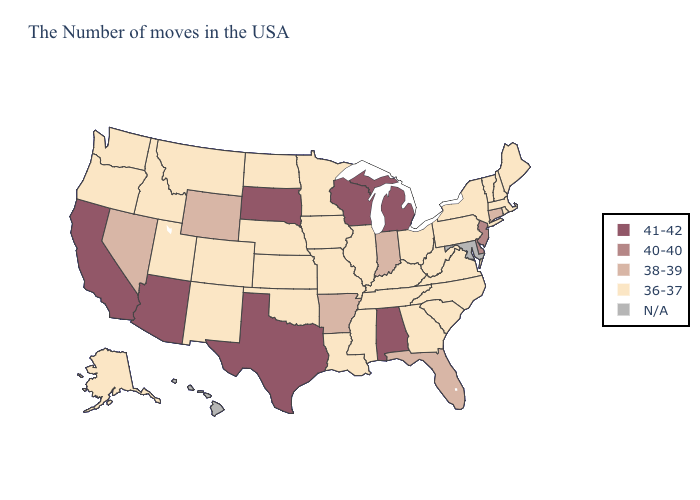Which states have the highest value in the USA?
Quick response, please. Michigan, Alabama, Wisconsin, Texas, South Dakota, Arizona, California. Does the first symbol in the legend represent the smallest category?
Short answer required. No. Name the states that have a value in the range 40-40?
Short answer required. New Jersey, Delaware. Name the states that have a value in the range 40-40?
Write a very short answer. New Jersey, Delaware. Among the states that border Arizona , does Nevada have the highest value?
Short answer required. No. Among the states that border Iowa , which have the highest value?
Concise answer only. Wisconsin, South Dakota. Which states have the highest value in the USA?
Short answer required. Michigan, Alabama, Wisconsin, Texas, South Dakota, Arizona, California. Name the states that have a value in the range 36-37?
Answer briefly. Maine, Massachusetts, Rhode Island, New Hampshire, Vermont, New York, Pennsylvania, Virginia, North Carolina, South Carolina, West Virginia, Ohio, Georgia, Kentucky, Tennessee, Illinois, Mississippi, Louisiana, Missouri, Minnesota, Iowa, Kansas, Nebraska, Oklahoma, North Dakota, Colorado, New Mexico, Utah, Montana, Idaho, Washington, Oregon, Alaska. What is the highest value in states that border Iowa?
Give a very brief answer. 41-42. Does Rhode Island have the highest value in the Northeast?
Write a very short answer. No. Does South Dakota have the highest value in the MidWest?
Be succinct. Yes. Among the states that border Oregon , does California have the highest value?
Answer briefly. Yes. Is the legend a continuous bar?
Answer briefly. No. Does Michigan have the highest value in the USA?
Quick response, please. Yes. 